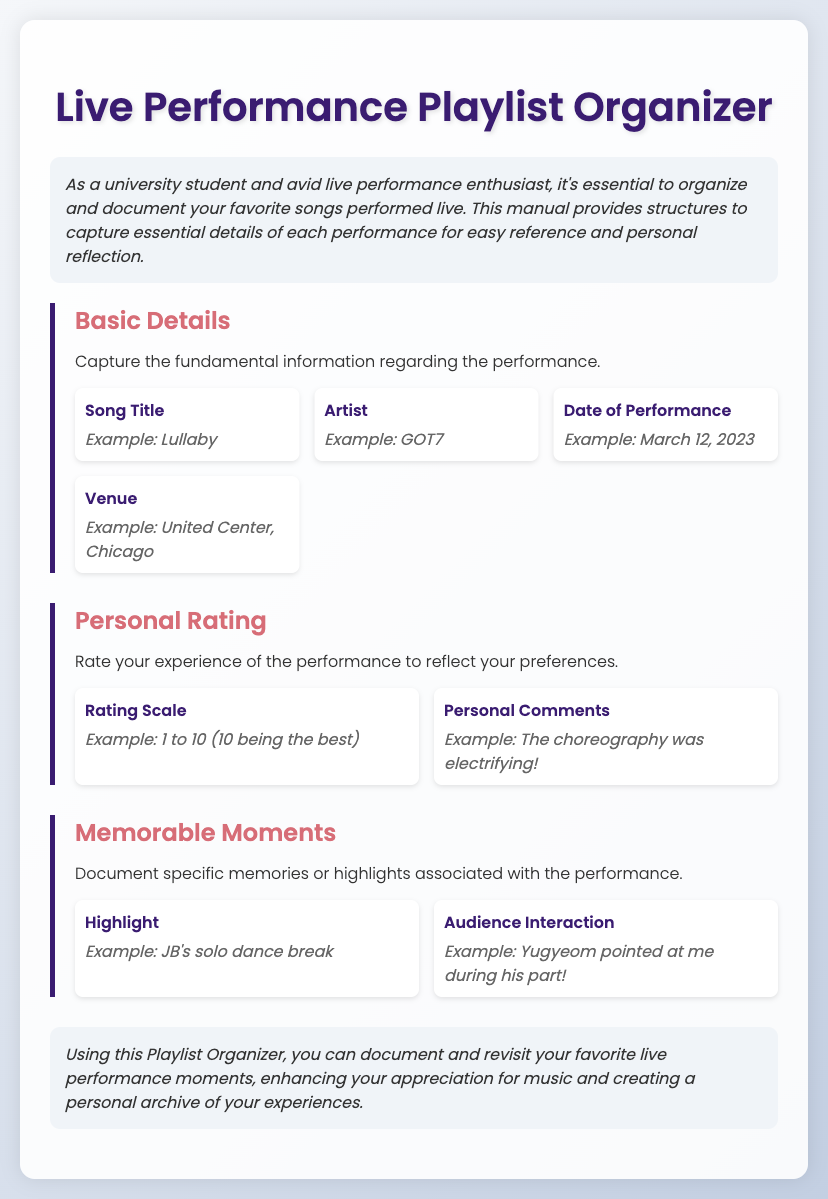What is the title of the manual? The title of the manual can be found at the top of the document, which is "Live Performance Playlist Organizer."
Answer: Live Performance Playlist Organizer Who is the artist mentioned in the examples? The artist example provided in the document is specifically noted in the basic details section.
Answer: GOT7 What date is given as an example of a performance? The document provides an example date for performances in the Basic Details section, which helps illustrate how to document the date.
Answer: March 12, 2023 What is the rating scale suggested for personal ratings? The suggested rating scale for personal ratings is explained in the Personal Rating section.
Answer: 1 to 10 What is a memorable moment highlighted in the document? The document features an example of a highlight related to memorable moments during a performance.
Answer: JB's solo dance break What serves as the main purpose of the document? The introduction section explains that the main purpose is to organize and document favorite songs performed live.
Answer: Organize and document How are personal comments categorized in the document? Personal comments are categorized under the Personal Rating section, indicating a specific way to reflect on the performance.
Answer: Personal Comments What type of experiences does the Playlist Organizer aim to capture? The conclusion summarizes the types of experiences the organizer aims to document, focusing on specific moments of performances.
Answer: Favorite live performance moments 